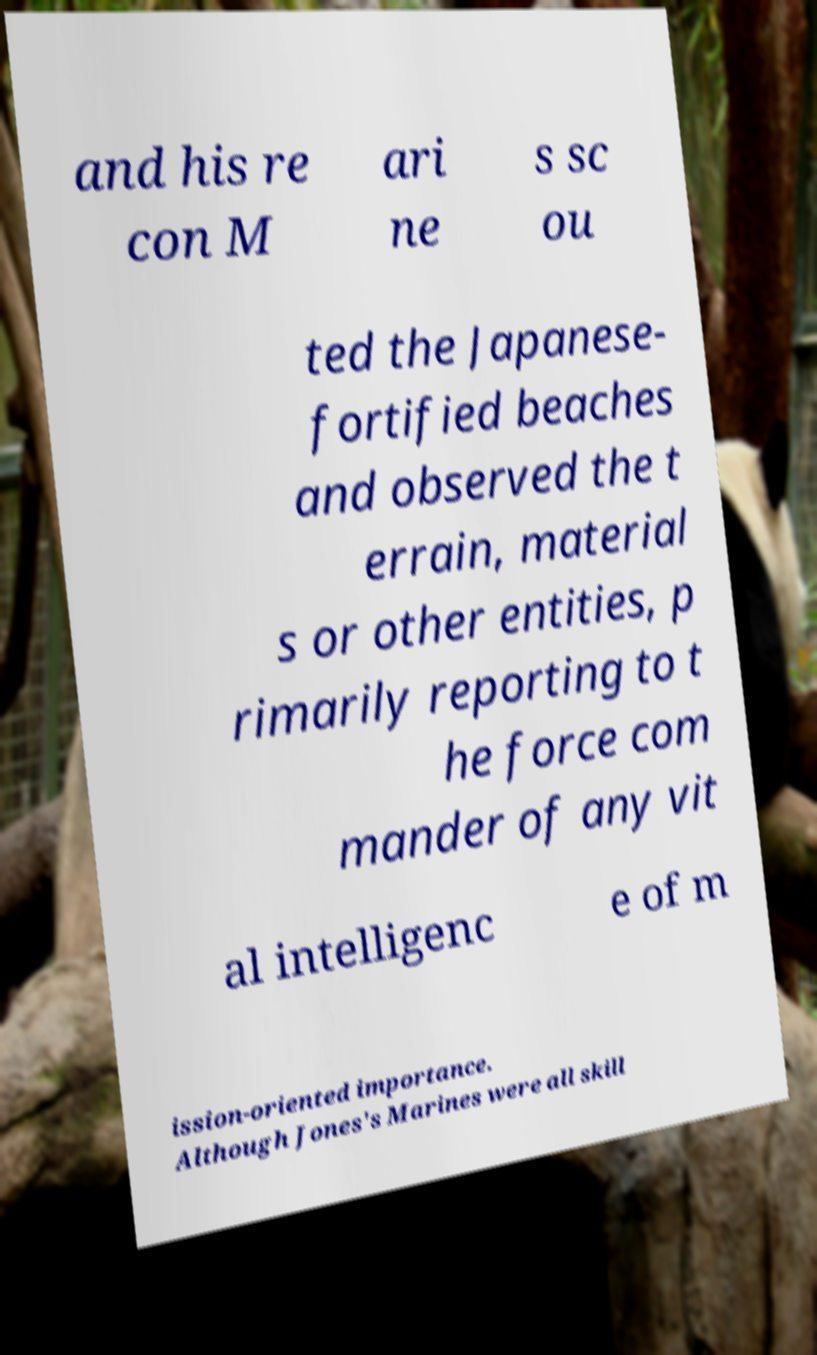There's text embedded in this image that I need extracted. Can you transcribe it verbatim? and his re con M ari ne s sc ou ted the Japanese- fortified beaches and observed the t errain, material s or other entities, p rimarily reporting to t he force com mander of any vit al intelligenc e of m ission-oriented importance. Although Jones's Marines were all skill 